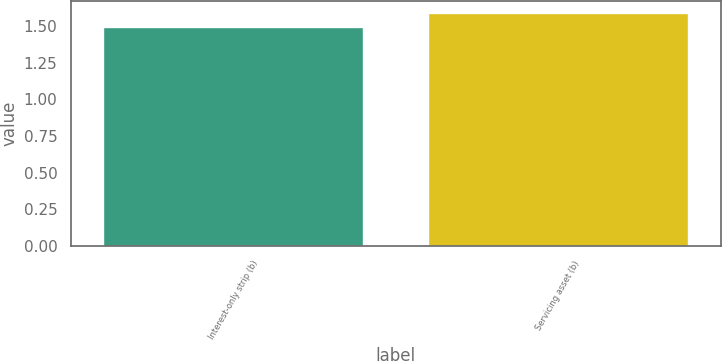Convert chart to OTSL. <chart><loc_0><loc_0><loc_500><loc_500><bar_chart><fcel>Interest-only strip (b)<fcel>Servicing asset (b)<nl><fcel>1.49<fcel>1.59<nl></chart> 